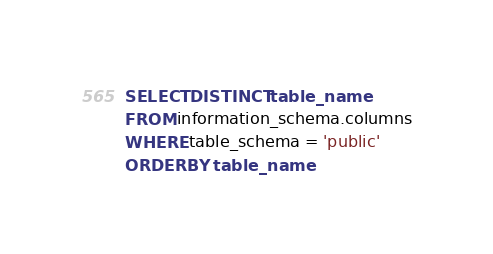<code> <loc_0><loc_0><loc_500><loc_500><_SQL_>SELECT DISTINCT table_name
FROM information_schema.columns
WHERE table_schema = 'public'
ORDER BY table_name</code> 